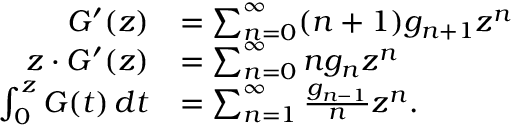Convert formula to latex. <formula><loc_0><loc_0><loc_500><loc_500>{ \begin{array} { r l } { G ^ { \prime } ( z ) } & { = \sum _ { n = 0 } ^ { \infty } ( n + 1 ) g _ { n + 1 } z ^ { n } } \\ { z \cdot G ^ { \prime } ( z ) } & { = \sum _ { n = 0 } ^ { \infty } n g _ { n } z ^ { n } } \\ { \int _ { 0 } ^ { z } G ( t ) \, d t } & { = \sum _ { n = 1 } ^ { \infty } { \frac { g _ { n - 1 } } { n } } z ^ { n } . } \end{array} }</formula> 